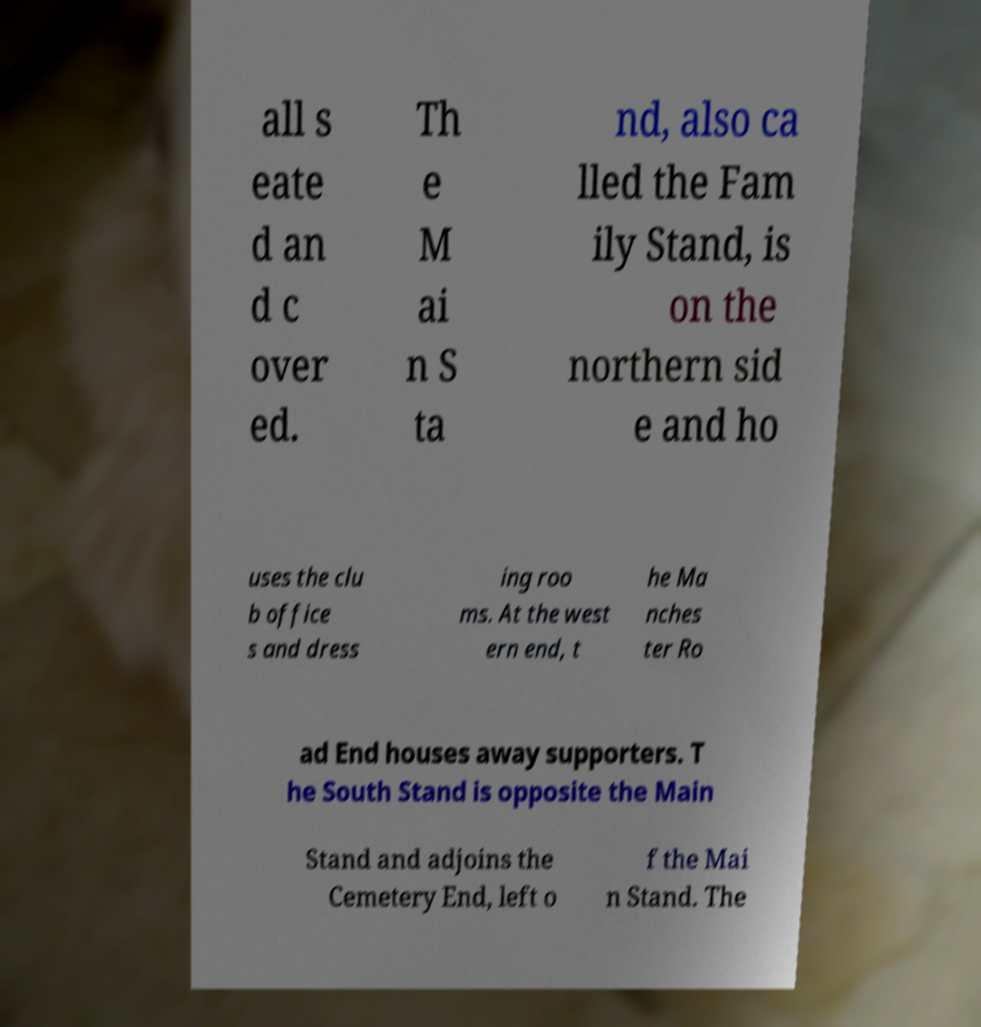There's text embedded in this image that I need extracted. Can you transcribe it verbatim? all s eate d an d c over ed. Th e M ai n S ta nd, also ca lled the Fam ily Stand, is on the northern sid e and ho uses the clu b office s and dress ing roo ms. At the west ern end, t he Ma nches ter Ro ad End houses away supporters. T he South Stand is opposite the Main Stand and adjoins the Cemetery End, left o f the Mai n Stand. The 